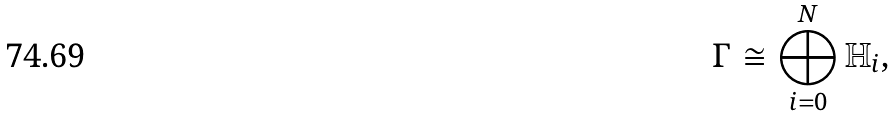<formula> <loc_0><loc_0><loc_500><loc_500>\Gamma \cong \bigoplus _ { i = 0 } ^ { N } \mathbb { H } _ { i } ,</formula> 